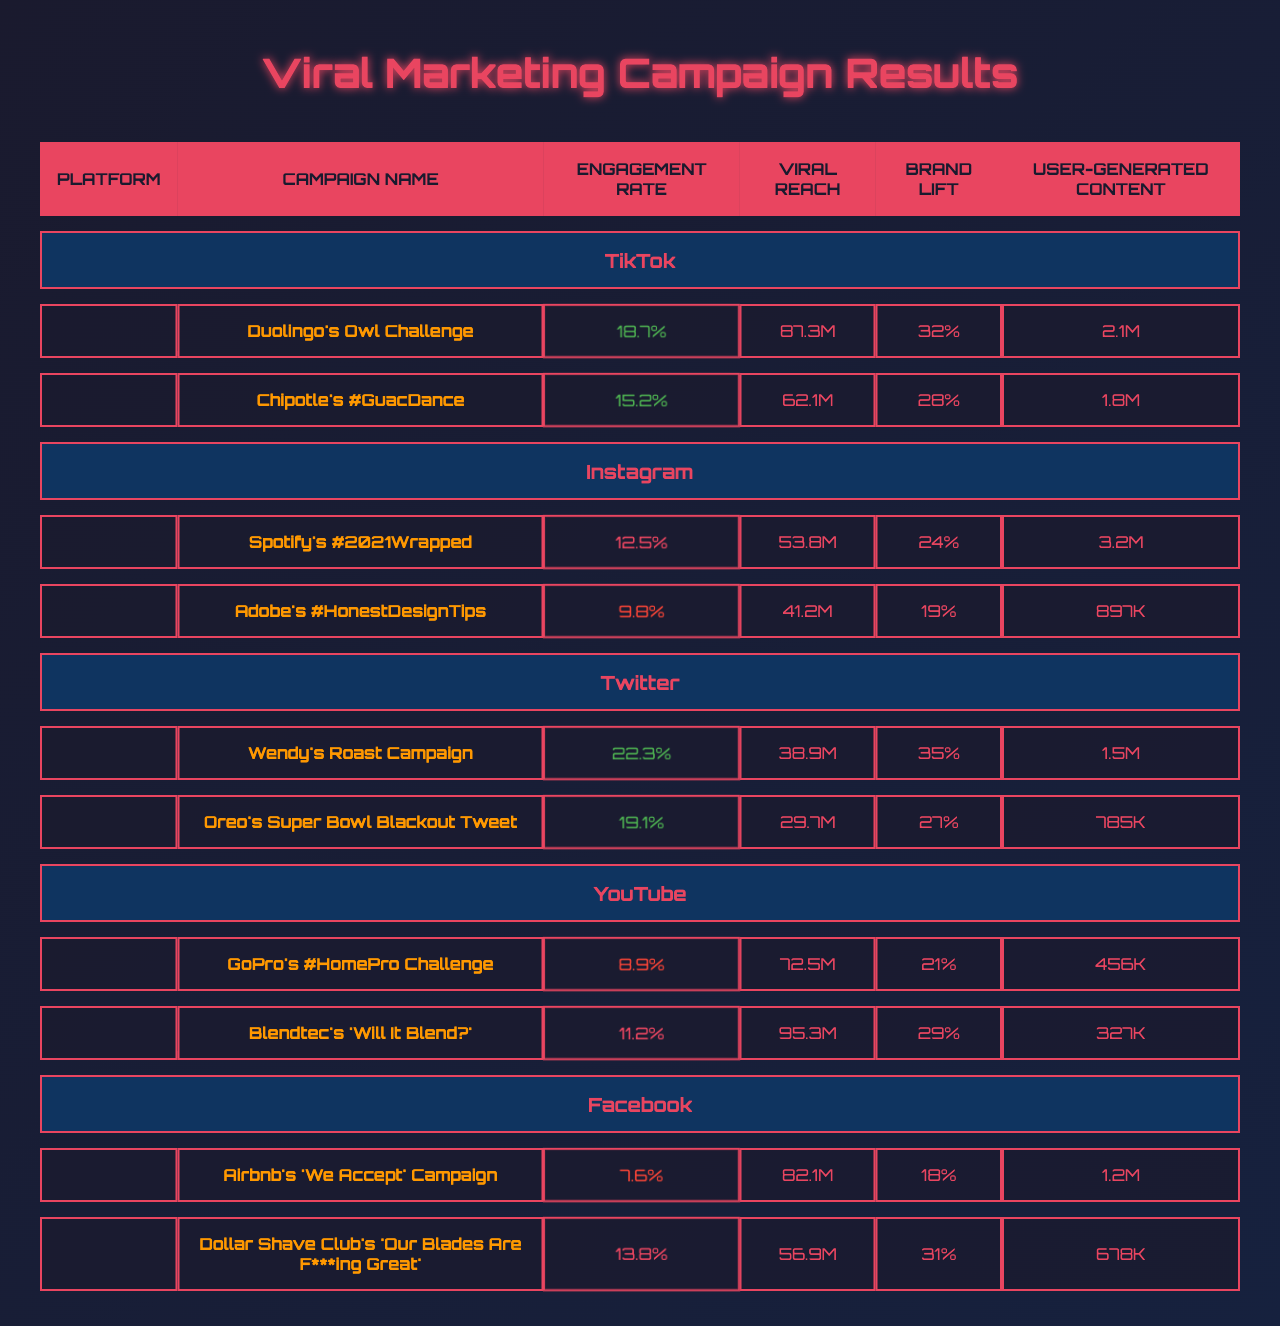What is the campaign with the highest engagement rate? By scanning the Engagement Rate column, the highest value is 22.3%, associated with Wendy's Roast Campaign.
Answer: Wendy's Roast Campaign How many user-generated content pieces were created for Duolingo's Owl Challenge? The User-Generated Content column shows that 2.1 million pieces were created for the Duolingo's Owl Challenge.
Answer: 2.1M Which platform had the lowest average engagement rate across its campaigns? The average engagement rates for each platform are calculated as follows: TikTok (18.7% + 15.2% = 16.9%), Instagram (12.5% + 9.8% = 11.15%), Twitter (22.3% + 19.1% = 20.7%), YouTube (8.9% + 11.2% = 10.05%), and Facebook (7.6% + 13.8% = 10.7%). The lowest is Facebook with an average of 10.7%.
Answer: Facebook What is the total viral reach of campaigns on Instagram? Adding the Viral Reach for the two campaigns on Instagram gives 53.8 million + 41.2 million = 95 million.
Answer: 95M Did any campaign surpass a 30% brand lift? By examining the Brand Lift column, Wendy's Roast Campaign (35%) and Dollar Shave Club's campaign (31%) exceed 30%.
Answer: Yes Which campaign had the highest viral reach, and what was its reach? Scanning the Viral Reach column shows Blendtec's 'Will It Blend?' with 95.3 million as the highest reach.
Answer: Blendtec's 'Will It Blend?', 95.3M How many total campaigns are listed in the table? There are 10 campaigns in total: 2 from TikTok, 2 from Instagram, 2 from Twitter, 2 from YouTube, and 2 from Facebook, providing a total of 2 + 2 + 2 + 2 + 2 = 10.
Answer: 10 Which platform had a campaign with the most user-generated content, and what was that amount? Checking the User-Generated Content column, Spotify's #2021Wrapped with 3.2 million is the highest amount, found under Instagram.
Answer: Instagram, 3.2M What is the difference in engagement rate between the highest and lowest campaigns? The highest engagement rate is 22.3% (Wendy's Roast Campaign) and the lowest is 7.6% (Airbnb's Campaign). The difference is 22.3% - 7.6% = 14.7%.
Answer: 14.7% Which campaign from TikTok had a higher engagement rate than the average engagement rate of Facebook's campaigns? The average engagement rate for Facebook's campaigns is (7.6% + 13.8%) / 2 = 10.7%. Both TikTok campaigns, Duolingo's Owl Challenge (18.7%) and Chipotle's #GuacDance (15.2%), exceed this.
Answer: Both TikTok campaigns exceed 